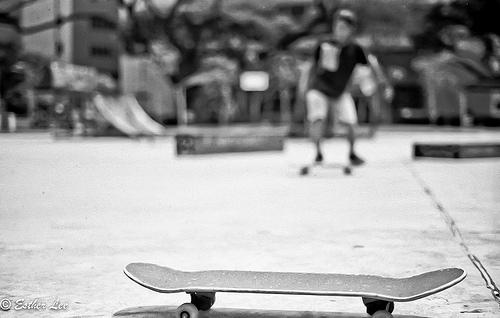Question: what is the boy doing?
Choices:
A. Reading.
B. Surfing.
C. Playing.
D. Skateboarding.
Answer with the letter. Answer: D Question: what is at the front of the picture?
Choices:
A. Tree.
B. The team.
C. Skateboard.
D. The garden.
Answer with the letter. Answer: C Question: what color is the picture?
Choices:
A. Sepia.
B. Red and blue.
C. Black and white.
D. Orange and purple.
Answer with the letter. Answer: C Question: what is he he riding on?
Choices:
A. Motorcycle.
B. Skateboard.
C. Horse.
D. Scooter.
Answer with the letter. Answer: B Question: what is in the background?
Choices:
A. Buildings.
B. Trees.
C. The team.
D. Ramps.
Answer with the letter. Answer: D Question: how many wheels on skateboard?
Choices:
A. Three.
B. Two.
C. Four.
D. Five.
Answer with the letter. Answer: C 